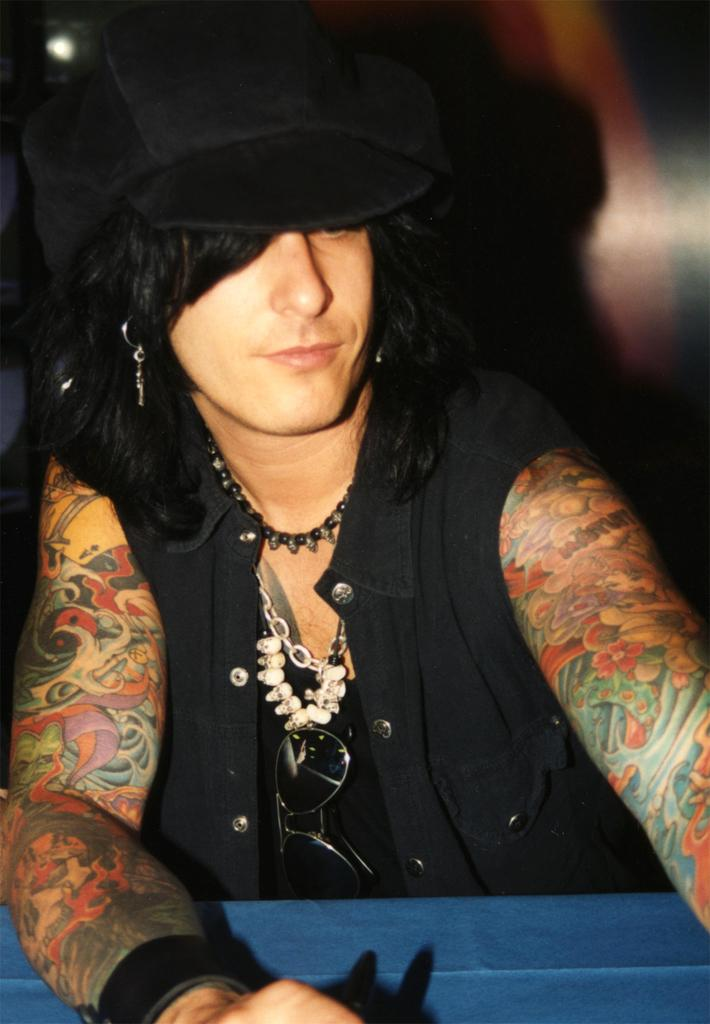What is present in the image besides the person? There is a wall in the image. What is the person wearing in the image? The person is wearing a black dress. What type of vessel is being used by the person in the image? There is no vessel present in the image; the person is simply standing near a wall while wearing a black dress. Can you tell me if the person in the image has received approval for something? There is no information about approval or any related context in the image. 